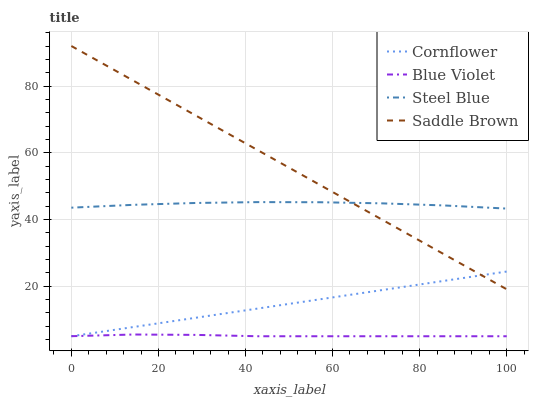Does Blue Violet have the minimum area under the curve?
Answer yes or no. Yes. Does Saddle Brown have the maximum area under the curve?
Answer yes or no. Yes. Does Steel Blue have the minimum area under the curve?
Answer yes or no. No. Does Steel Blue have the maximum area under the curve?
Answer yes or no. No. Is Cornflower the smoothest?
Answer yes or no. Yes. Is Steel Blue the roughest?
Answer yes or no. Yes. Is Blue Violet the smoothest?
Answer yes or no. No. Is Blue Violet the roughest?
Answer yes or no. No. Does Cornflower have the lowest value?
Answer yes or no. Yes. Does Steel Blue have the lowest value?
Answer yes or no. No. Does Saddle Brown have the highest value?
Answer yes or no. Yes. Does Steel Blue have the highest value?
Answer yes or no. No. Is Blue Violet less than Steel Blue?
Answer yes or no. Yes. Is Steel Blue greater than Cornflower?
Answer yes or no. Yes. Does Saddle Brown intersect Cornflower?
Answer yes or no. Yes. Is Saddle Brown less than Cornflower?
Answer yes or no. No. Is Saddle Brown greater than Cornflower?
Answer yes or no. No. Does Blue Violet intersect Steel Blue?
Answer yes or no. No. 